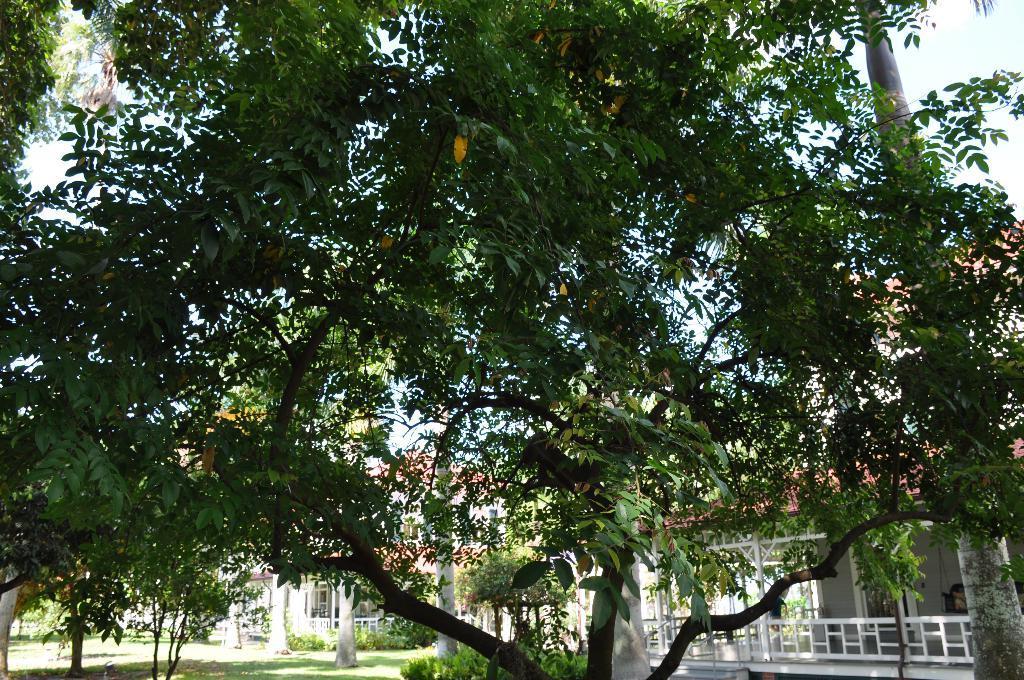Could you give a brief overview of what you see in this image? In this image we can see trees, houses. At the bottom of the image there is grass. 